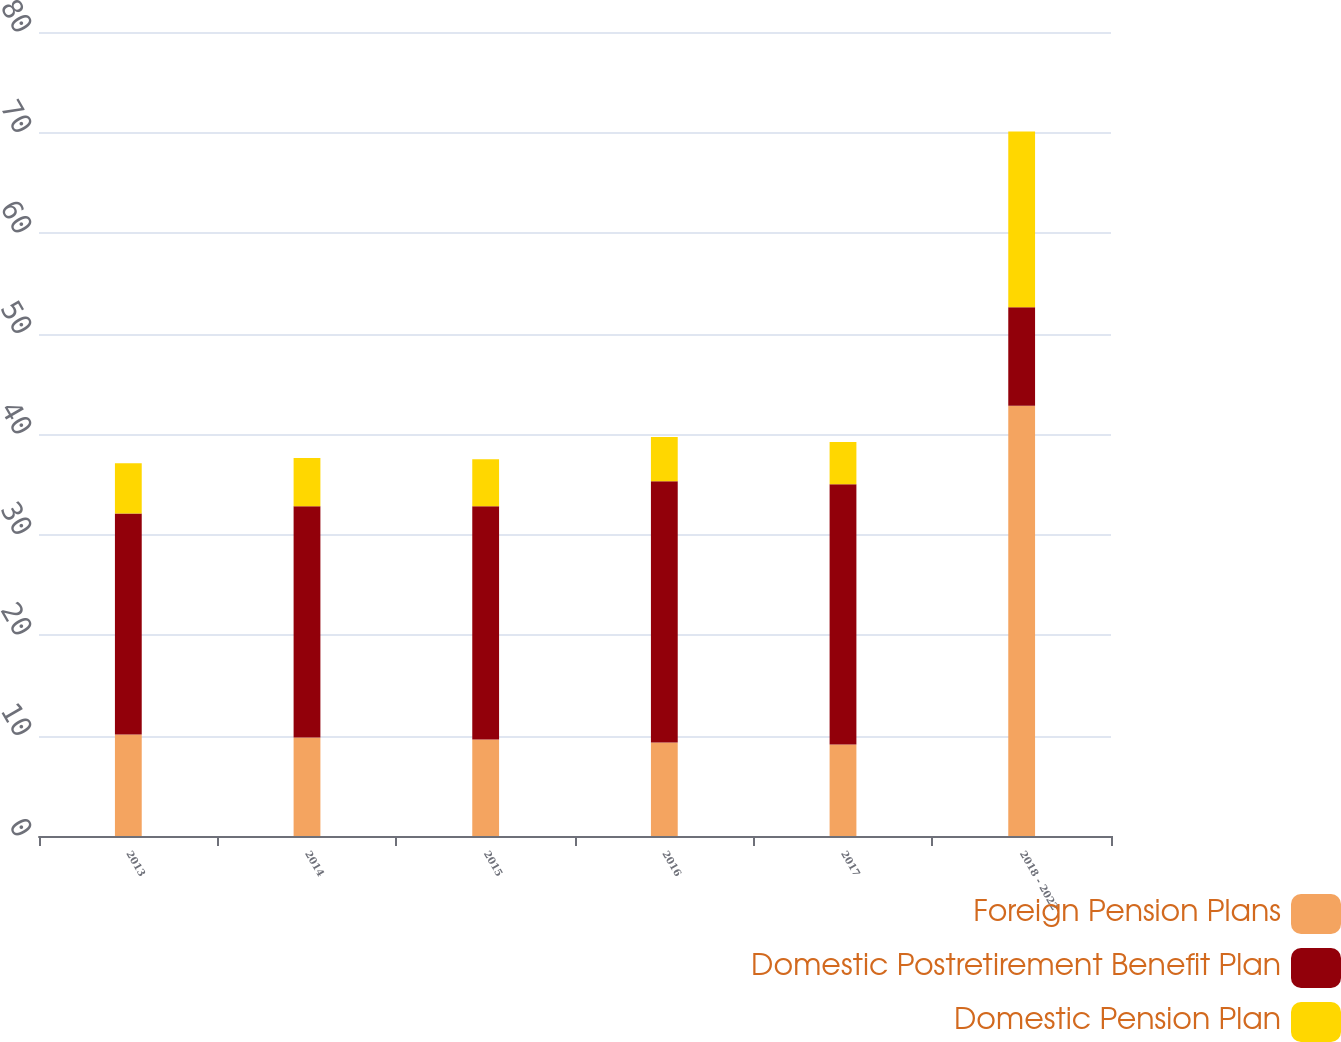<chart> <loc_0><loc_0><loc_500><loc_500><stacked_bar_chart><ecel><fcel>2013<fcel>2014<fcel>2015<fcel>2016<fcel>2017<fcel>2018 - 2022<nl><fcel>Foreign Pension Plans<fcel>10.1<fcel>9.8<fcel>9.6<fcel>9.3<fcel>9.1<fcel>42.8<nl><fcel>Domestic Postretirement Benefit Plan<fcel>22<fcel>23<fcel>23.2<fcel>26<fcel>25.9<fcel>9.8<nl><fcel>Domestic Pension Plan<fcel>5<fcel>4.8<fcel>4.7<fcel>4.4<fcel>4.2<fcel>17.5<nl></chart> 